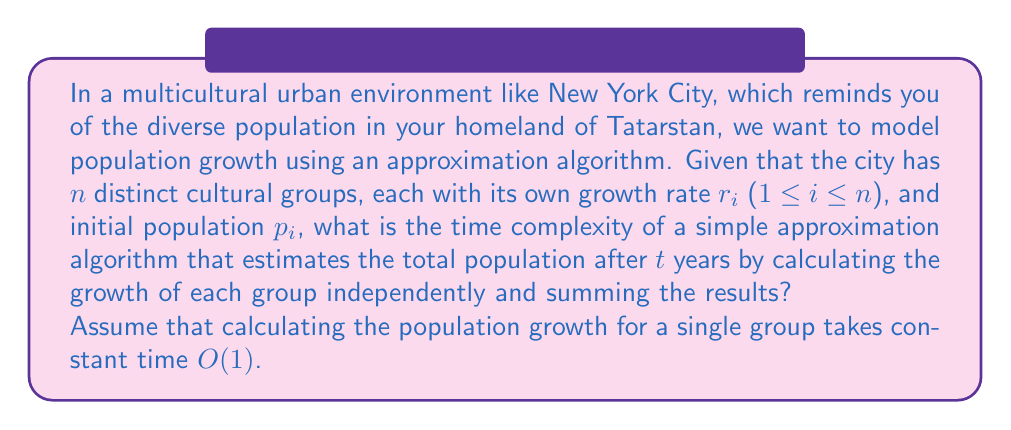Provide a solution to this math problem. To solve this problem, let's break it down step-by-step:

1) First, we need to understand what the algorithm does:
   - For each cultural group, it calculates the population after $t$ years.
   - It then sums up these individual populations to get the total.

2) Let's analyze the time complexity:
   - We have $n$ distinct cultural groups.
   - For each group, we perform a constant time operation $O(1)$ to calculate its population after $t$ years.
   - We do this for all $n$ groups, so this step takes $O(n)$ time.

3) After calculating all individual populations, we need to sum them up:
   - Summing $n$ numbers takes $O(n)$ time.

4) The total time complexity is the sum of the time taken for individual calculations and the final summation:
   $O(n) + O(n) = O(n)$

5) This is a simple approximation algorithm because it doesn't account for interactions between cultural groups, which could affect growth rates in complex ways. However, it provides a reasonable estimate with a linear time complexity.

Therefore, the time complexity of this approximation algorithm is $O(n)$, where $n$ is the number of distinct cultural groups in the urban environment.
Answer: $O(n)$ 